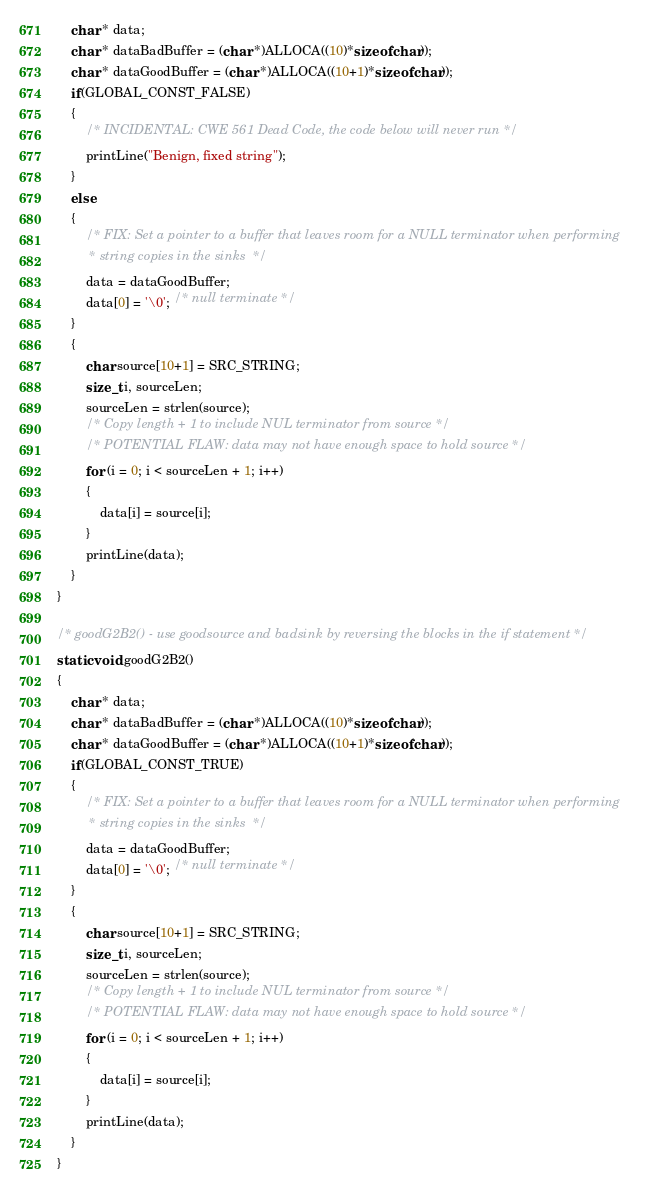<code> <loc_0><loc_0><loc_500><loc_500><_C_>    char * data;
    char * dataBadBuffer = (char *)ALLOCA((10)*sizeof(char));
    char * dataGoodBuffer = (char *)ALLOCA((10+1)*sizeof(char));
    if(GLOBAL_CONST_FALSE)
    {
        /* INCIDENTAL: CWE 561 Dead Code, the code below will never run */
        printLine("Benign, fixed string");
    }
    else
    {
        /* FIX: Set a pointer to a buffer that leaves room for a NULL terminator when performing
         * string copies in the sinks  */
        data = dataGoodBuffer;
        data[0] = '\0'; /* null terminate */
    }
    {
        char source[10+1] = SRC_STRING;
        size_t i, sourceLen;
        sourceLen = strlen(source);
        /* Copy length + 1 to include NUL terminator from source */
        /* POTENTIAL FLAW: data may not have enough space to hold source */
        for (i = 0; i < sourceLen + 1; i++)
        {
            data[i] = source[i];
        }
        printLine(data);
    }
}

/* goodG2B2() - use goodsource and badsink by reversing the blocks in the if statement */
static void goodG2B2()
{
    char * data;
    char * dataBadBuffer = (char *)ALLOCA((10)*sizeof(char));
    char * dataGoodBuffer = (char *)ALLOCA((10+1)*sizeof(char));
    if(GLOBAL_CONST_TRUE)
    {
        /* FIX: Set a pointer to a buffer that leaves room for a NULL terminator when performing
         * string copies in the sinks  */
        data = dataGoodBuffer;
        data[0] = '\0'; /* null terminate */
    }
    {
        char source[10+1] = SRC_STRING;
        size_t i, sourceLen;
        sourceLen = strlen(source);
        /* Copy length + 1 to include NUL terminator from source */
        /* POTENTIAL FLAW: data may not have enough space to hold source */
        for (i = 0; i < sourceLen + 1; i++)
        {
            data[i] = source[i];
        }
        printLine(data);
    }
}
</code> 